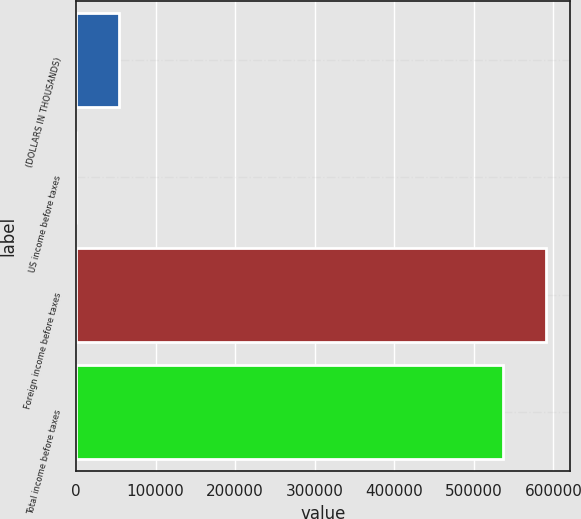<chart> <loc_0><loc_0><loc_500><loc_500><bar_chart><fcel>(DOLLARS IN THOUSANDS)<fcel>US income before taxes<fcel>Foreign income before taxes<fcel>Total income before taxes<nl><fcel>53728.5<fcel>24<fcel>590750<fcel>537045<nl></chart> 